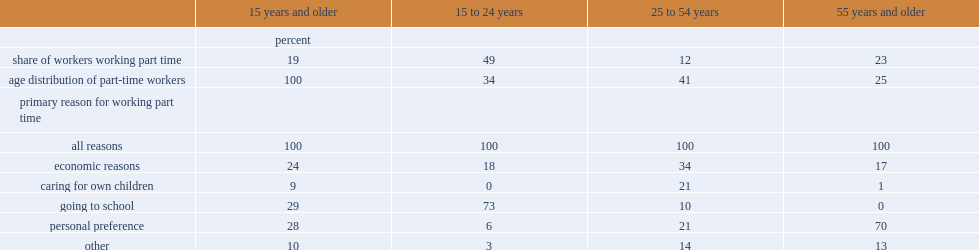Parse the full table. {'header': ['', '15 years and older', '15 to 24 years', '25 to 54 years', '55 years and older'], 'rows': [['', 'percent', '', '', ''], ['share of workers working part time', '19', '49', '12', '23'], ['age distribution of part-time workers', '100', '34', '41', '25'], ['primary reason for working part time', '', '', '', ''], ['all reasons', '100', '100', '100', '100'], ['economic reasons', '24', '18', '34', '17'], ['caring for own children', '9', '0', '21', '1'], ['going to school', '29', '73', '10', '0'], ['personal preference', '28', '6', '21', '70'], ['other', '10', '3', '14', '13']]} What was the percentage point of youth aged 15 to 24 worked part time? 49.0. What was the percentage point of people aged 55 and older worked part time? 23.0. What was the percentage point of people in the core working ages of 25 to 54 worked part time? 12.0. What was the percentage point of youth aged 15 years and older worked part-time for the reason of "going to school"? 29.0. What was the percentage point of youth aged 15 years and older worked part-time for the reason of "personal preference"? 28.0. What was the percentage point of youth aged 15 years and older worked part-time for the reason of going to school? 73.0. What was the top reason for workers aged 55 and older to work part-time? Personal preference. What was the percentage point of youth aged 15 years and older worked part-time for the reason of going to school? 70.0. What was the share of people in the core working ages of 25 to 54 comprised the part-time workforce? 41.0. 